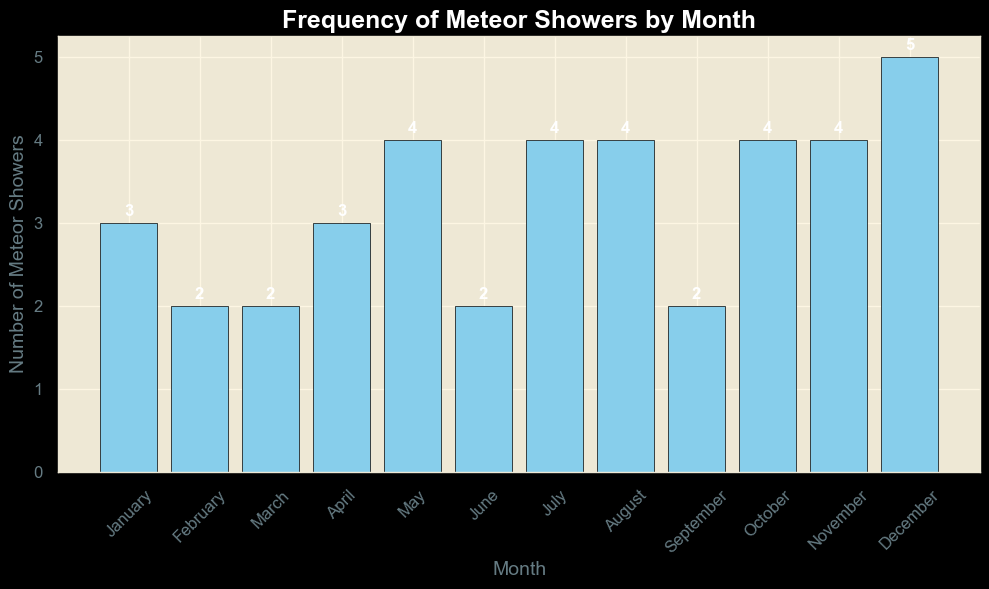What's the total number of meteor showers from June to December? Add the numbers of meteor showers from June (2), July (4), August (4), September (2), October (4), November (4), and December (5). So, 2 + 4 + 4 + 2 + 4 + 4 + 5 = 25.
Answer: 25 Which month has the highest frequency of meteor showers? Check the heights of the bars and find that December has the tallest bar with a height of 5.
Answer: December Are there more meteor showers in the second half of the year (July-December) than in the first half (January-June)? Sum the meteor showers from January to June (3 + 2 + 2 + 3 + 4 + 2 = 16) and from July to December (4 + 4 + 4 + 2 + 4 + 4 + 5 = 27). 27 is greater than 16.
Answer: Yes Which months have an equal number of meteor showers? Identify the heights of the bars that are the same: look for pairs or groups. February and March both have 2; April and January both have 3; May, July, August, October, and November each have 4.
Answer: February and March; January and April; May, July, August, October, and November What's the average number of meteor showers per month? Sum all meteor showers (3+2+2+3+4+2+4+4+2+4+4+5 = 39) and divide by the number of months (12). The average is 39/12 = 3.25.
Answer: 3.25 By how much do December meteor showers exceed the average number per month? December has 5 meteor showers. The average is 3.25. The difference is 5 - 3.25 = 1.75.
Answer: 1.75 Which month shows the lowest frequency of meteor showers and what is the number? Find the shortest bars: February, March, and June, each with a height of 2.
Answer: February, March, June If each month must have at least 3 meteor showers to be classified as high frequency, how many months qualify? Count the bars with 3 or more meteor showers: January (3), April (3), May (4), July (4), August (4), October (4), November (4), and December (5). That's 8 months.
Answer: 8 